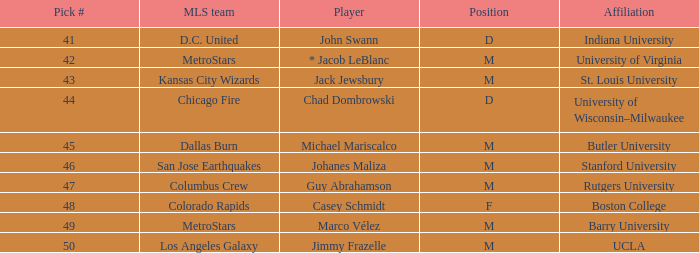Which MLS team has the #41 pick? D.C. United. 